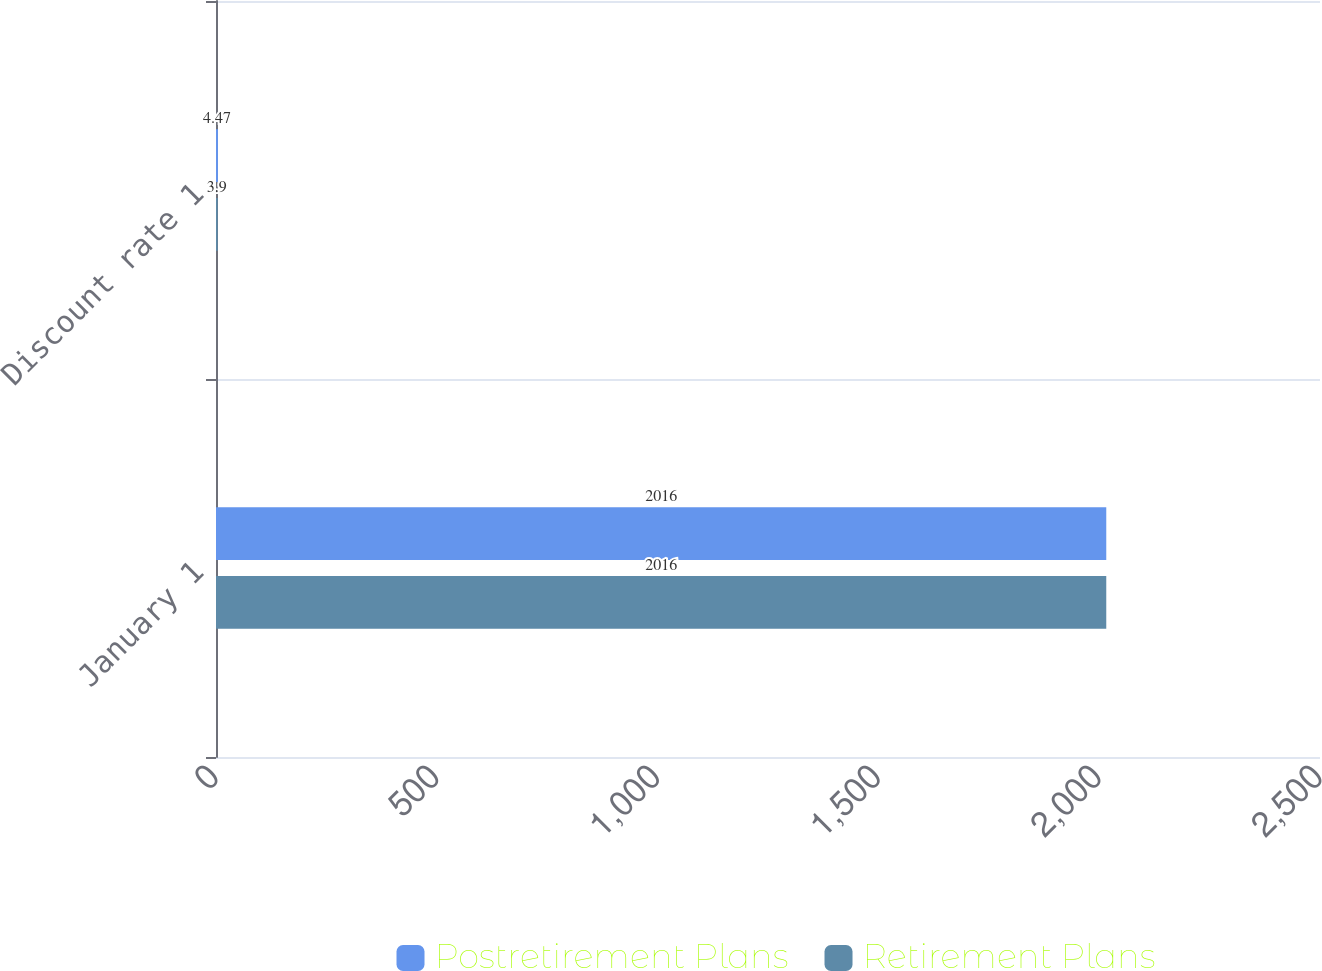Convert chart to OTSL. <chart><loc_0><loc_0><loc_500><loc_500><stacked_bar_chart><ecel><fcel>January 1<fcel>Discount rate 1<nl><fcel>Postretirement Plans<fcel>2016<fcel>4.47<nl><fcel>Retirement Plans<fcel>2016<fcel>3.9<nl></chart> 